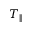<formula> <loc_0><loc_0><loc_500><loc_500>T _ { \| }</formula> 